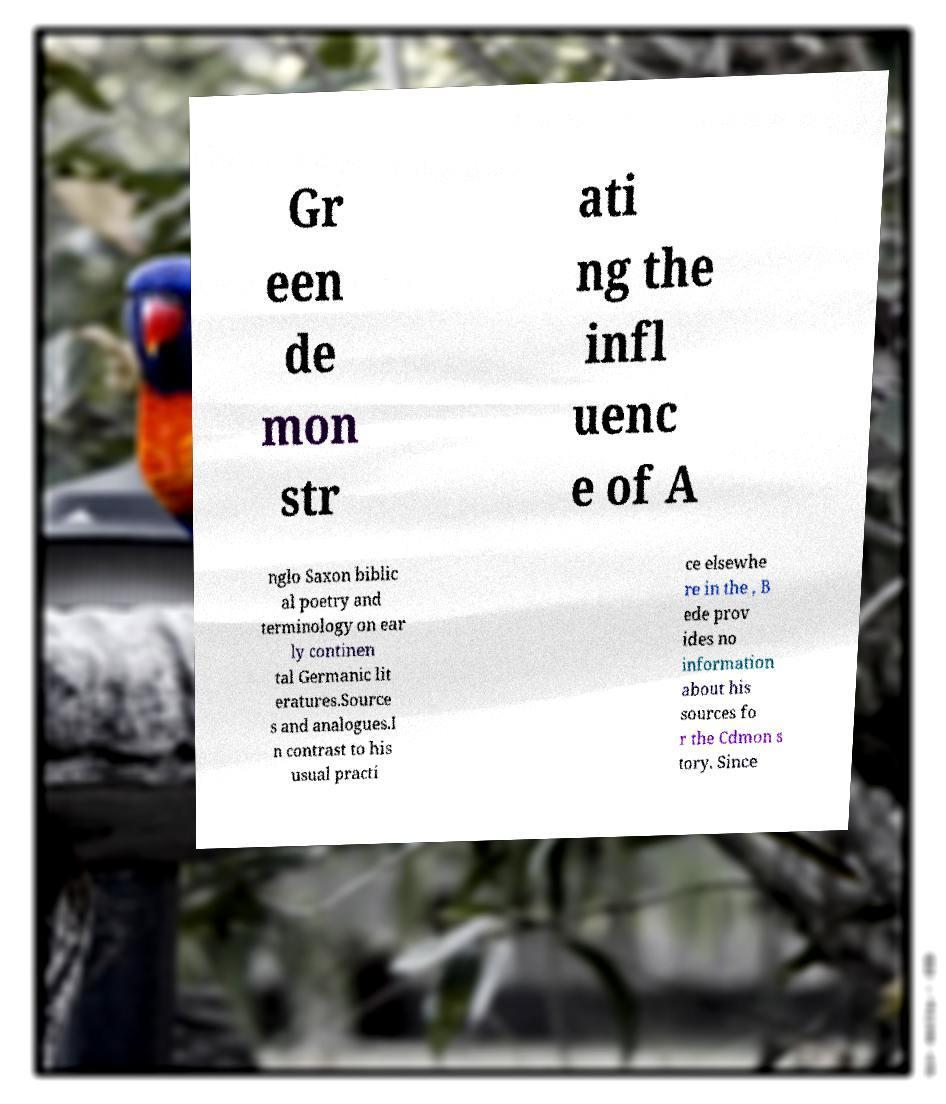Could you extract and type out the text from this image? Gr een de mon str ati ng the infl uenc e of A nglo Saxon biblic al poetry and terminology on ear ly continen tal Germanic lit eratures.Source s and analogues.I n contrast to his usual practi ce elsewhe re in the , B ede prov ides no information about his sources fo r the Cdmon s tory. Since 